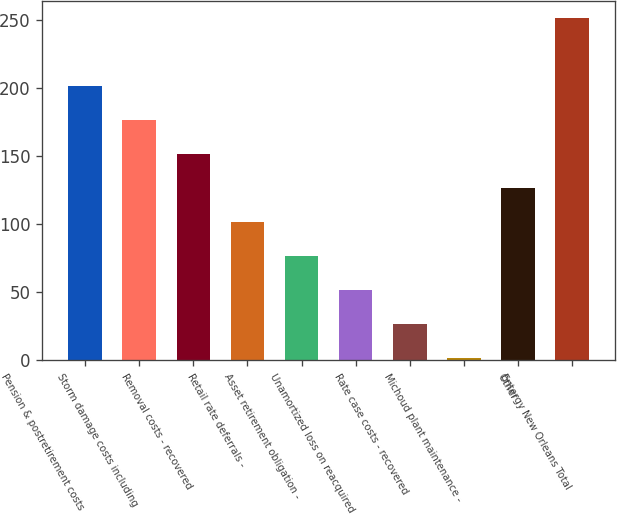Convert chart. <chart><loc_0><loc_0><loc_500><loc_500><bar_chart><fcel>Pension & postretirement costs<fcel>Storm damage costs including<fcel>Removal costs - recovered<fcel>Retail rate deferrals -<fcel>Asset retirement obligation -<fcel>Unamortized loss on reacquired<fcel>Rate case costs - recovered<fcel>Michoud plant maintenance -<fcel>Other<fcel>Entergy New Orleans Total<nl><fcel>201.4<fcel>176.4<fcel>151.4<fcel>101.4<fcel>76.4<fcel>51.4<fcel>26.4<fcel>1.4<fcel>126.4<fcel>251.4<nl></chart> 